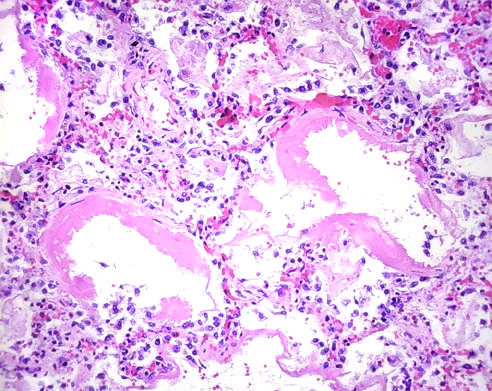what are lined by bright pink hyaline membranes?
Answer the question using a single word or phrase. Alveoli 